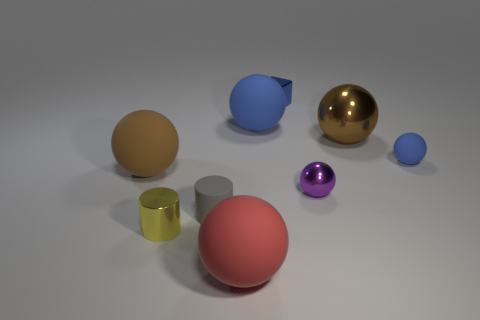Subtract all large blue matte balls. How many balls are left? 5 Subtract all purple cubes. How many brown balls are left? 2 Subtract 1 blocks. How many blocks are left? 0 Add 1 rubber cylinders. How many objects exist? 10 Subtract all brown balls. How many balls are left? 4 Subtract all cubes. How many objects are left? 8 Subtract all blue matte cylinders. Subtract all tiny cylinders. How many objects are left? 7 Add 8 big red objects. How many big red objects are left? 9 Add 1 large yellow blocks. How many large yellow blocks exist? 1 Subtract 0 cyan cubes. How many objects are left? 9 